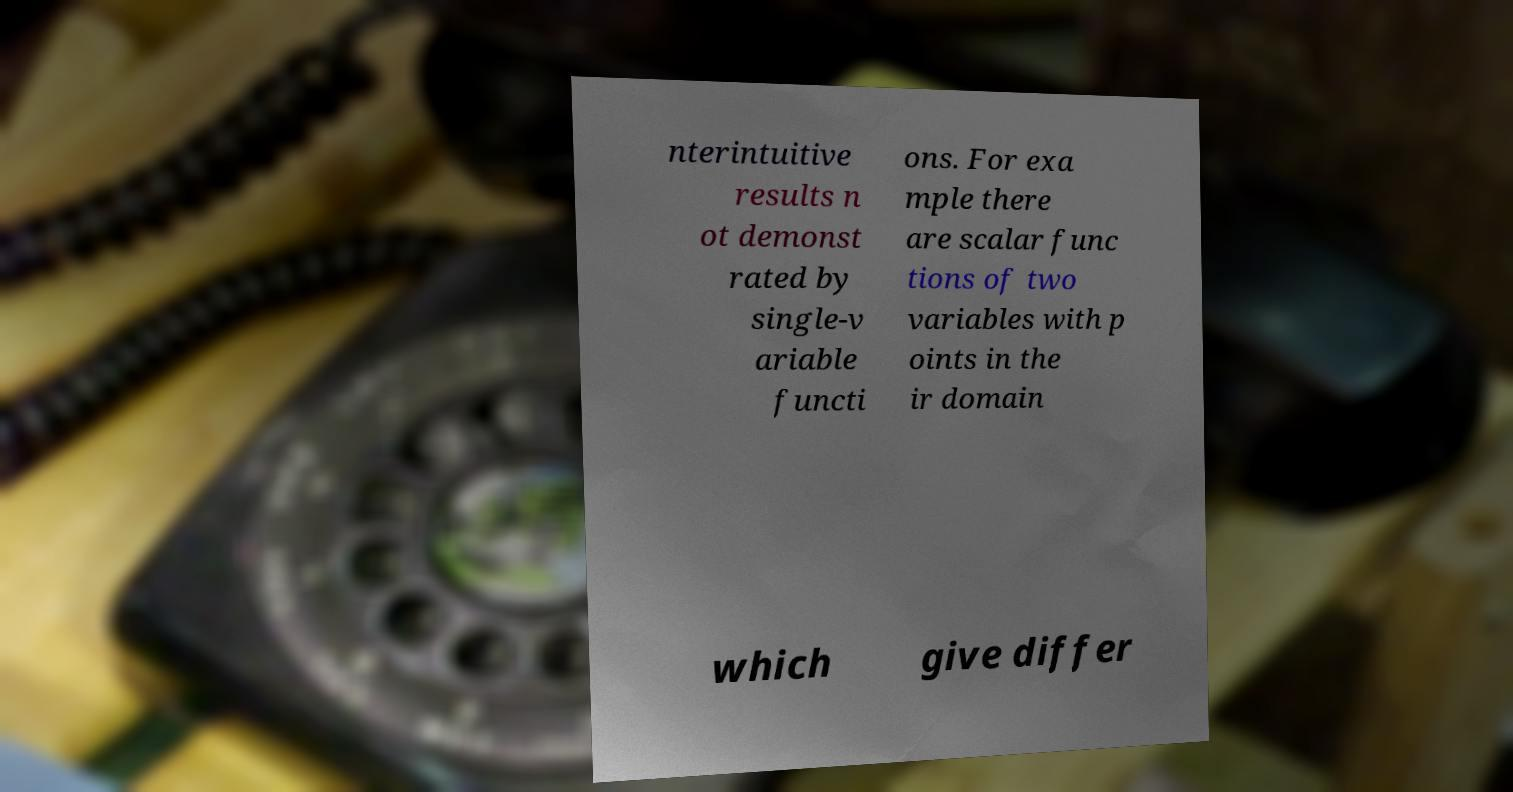There's text embedded in this image that I need extracted. Can you transcribe it verbatim? nterintuitive results n ot demonst rated by single-v ariable functi ons. For exa mple there are scalar func tions of two variables with p oints in the ir domain which give differ 